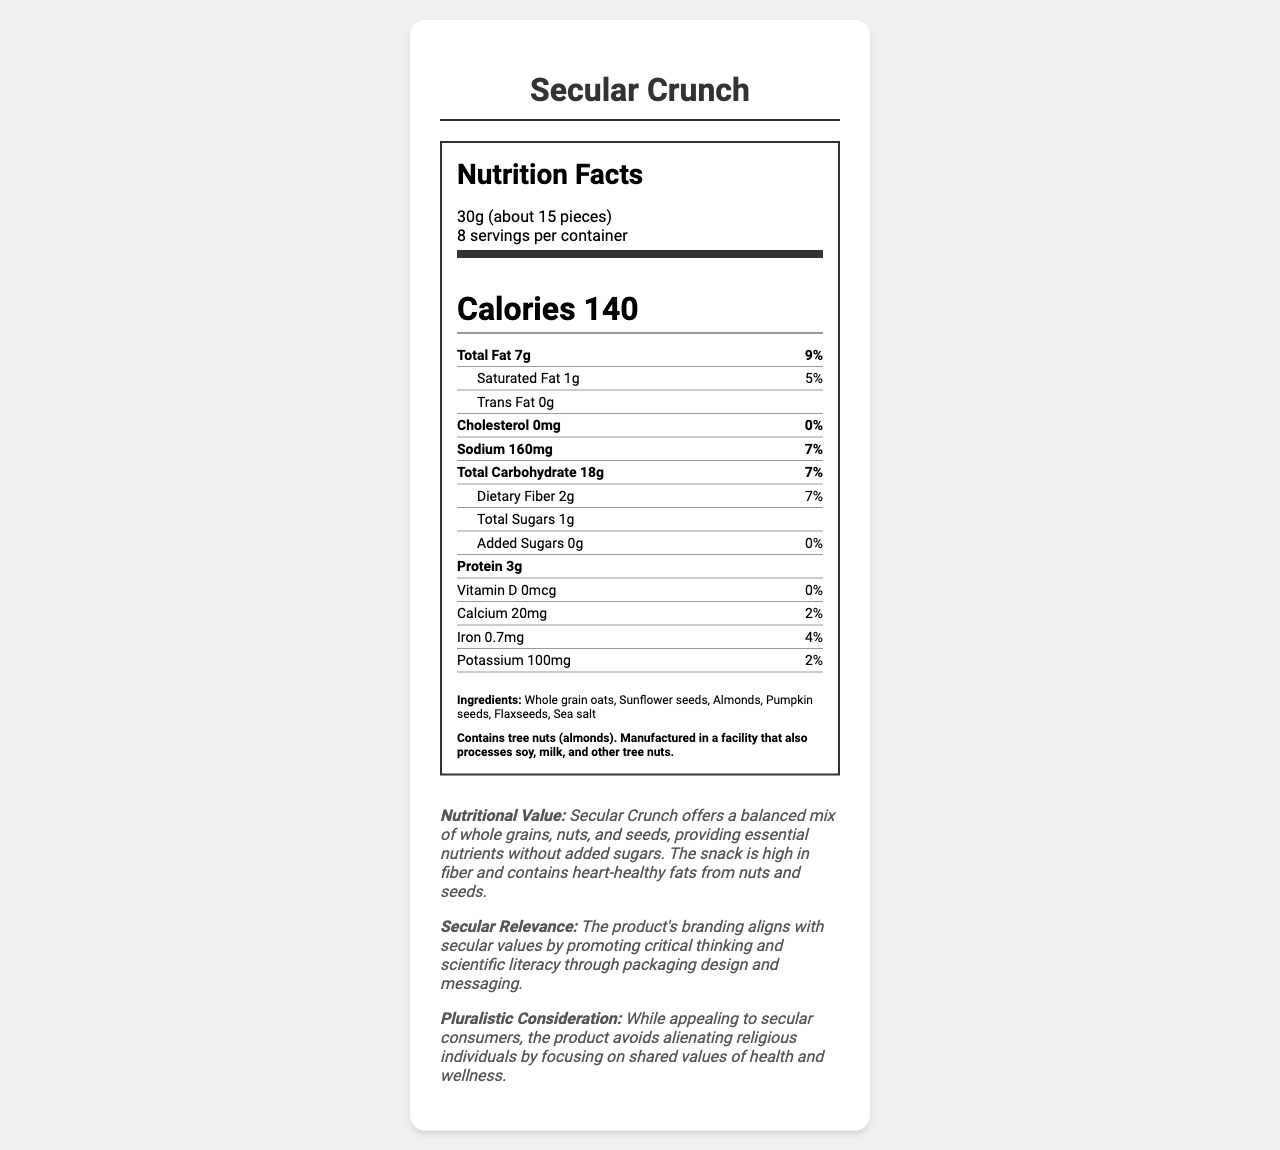what is the serving size? The serving size is explicitly mentioned at the top of the nutrition label.
Answer: 30g (about 15 pieces) how many calories are there per serving? The label shows the calories value in a larger font size just below the serving information.
Answer: 140 how much total fat is in one serving? This information is displayed under the "Total Fat" section of the nutrition label.
Answer: 7g what is the daily value percentage for total carbohydrates? The daily value for total carbohydrates is listed next to the amount in grams.
Answer: 7% does the product contain any added sugars? The label states "Added Sugars 0g 0%".
Answer: No which ingredient is highlighted as an allergen? The allergen information clearly mentions that the product contains tree nuts (almonds).
Answer: Almonds which of the following best describes the central theme of the product's packaging? A. Eco-friendly B. Secular values C. Allergen-free D. High protein The packaging includes secular quotes and an Enlightenment-inspired design, emphasizing secular values.
Answer: B what is the amount of protein per serving? A. 2g B. 3g C. 4g D. 5g The amount of protein per serving, according to the label, is 3g.
Answer: B how would you describe the nutritional value of this snack? The academic analysis section notes that the snack offers a balanced mix of whole grains, nuts, and seeds.
Answer: Balanced mix of whole grains, nuts, and seeds, providing essential nutrients without added sugars which two nutrients have the same daily value percentage? A. Iron and Calcium B. Dietary Fiber and Total Carbohydrate C. Protein and Total Sugars D. Vitamin D and Potassium Both dietary fiber and total carbohydrate have a daily value percentage of 7%.
Answer: B is the packaging recyclable? One of the packaging features lists "Recyclable cardboard box".
Answer: Yes summarize the main idea of the document. The document comprehensively presents the nutritional information and the unique secular branding and packaging aspects of the product.
Answer: The document provides a detailed nutrition facts label for "Secular Crunch," a snack product. It includes serving information, calories, nutrient amounts and daily values, ingredients, allergen information, and packaging features. The product is branded with secular-themed packaging promoting critical thinking and shared values of health. does the facility process any other allergenic ingredients? The allergen information mentions that the facility also processes soy, milk, and other tree nuts.
Answer: Yes how many servings are in the package? The serving information indicates there are 8 servings per container.
Answer: 8 does the snack align with pluralistic values? The academic analysis specifically mentions that the product avoids alienating religious individuals by focusing on shared values of health and wellness.
Answer: Yes how much dietary fiber is in one serving? The dietary fiber amount is given in the nutritional label.
Answer: 2g how much potassium does one serving contain? The nutritional label lists potassium as 100mg.
Answer: 100mg are there any added preservatives mentioned in the ingredients? The ingredients listed are whole grain oats, sunflower seeds, almonds, pumpkin seeds, flaxseeds, and sea salt, with no mention of preservatives.
Answer: No 